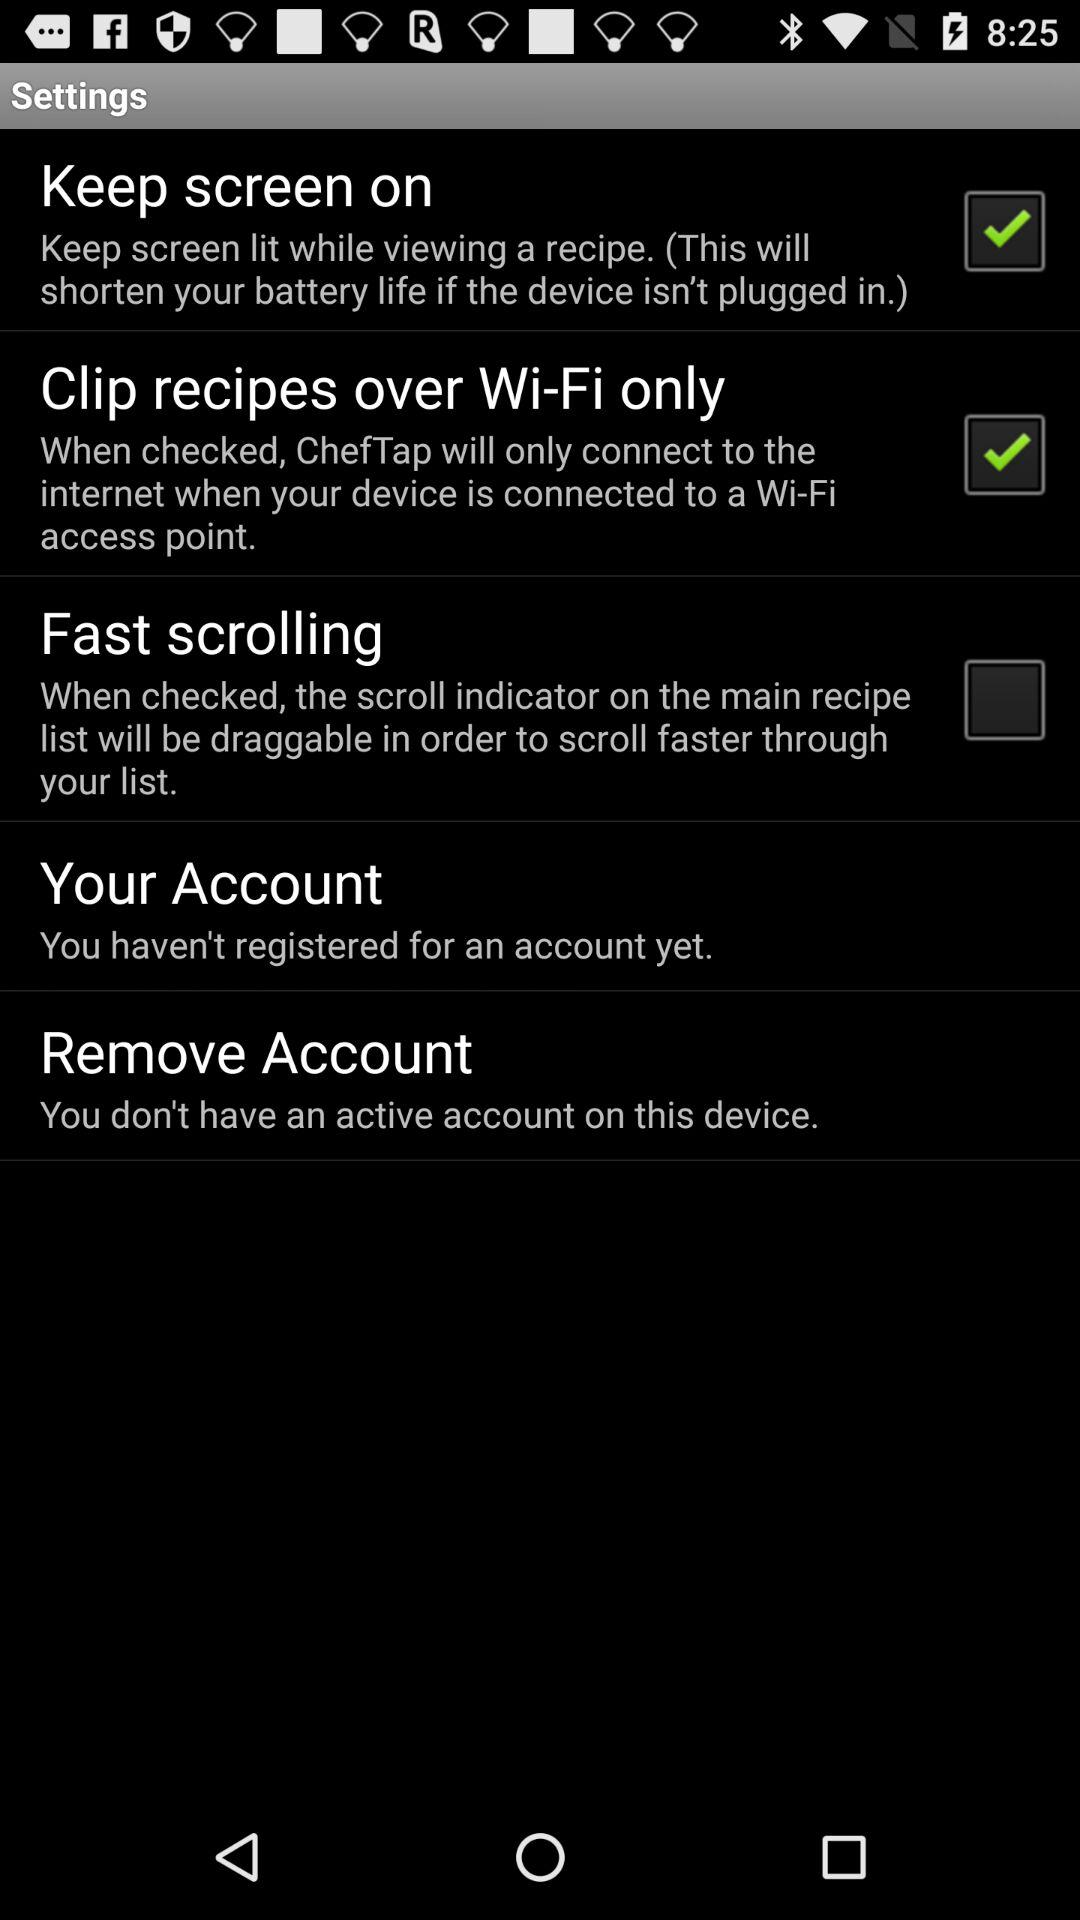Which email address is used for the account?
When the provided information is insufficient, respond with <no answer>. <no answer> 